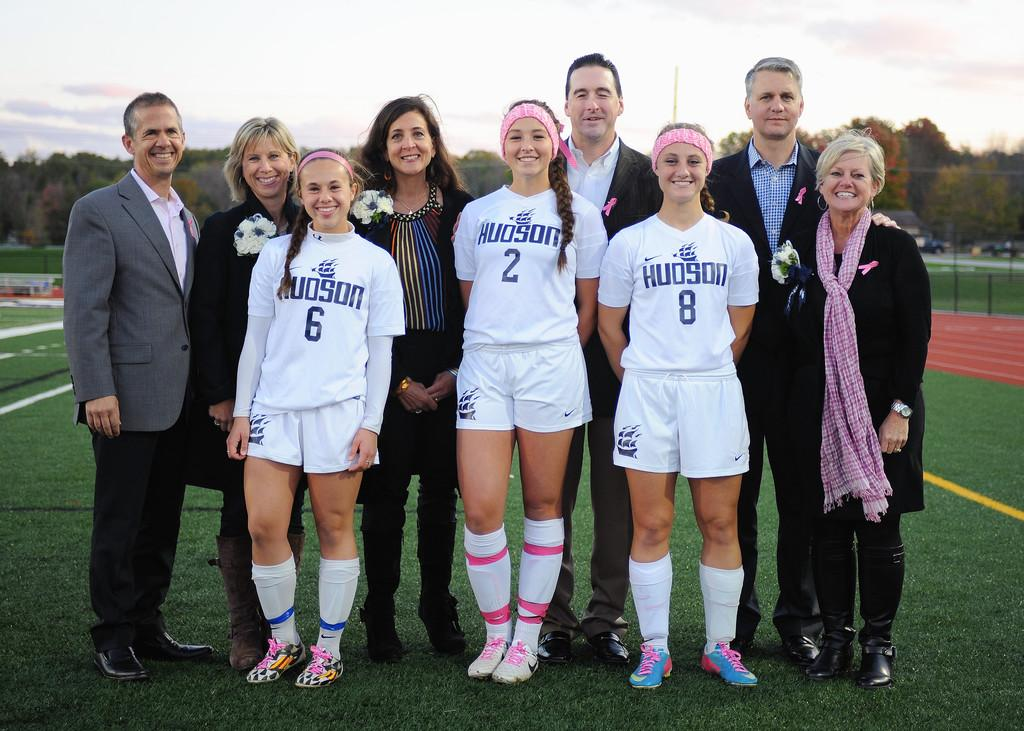<image>
Render a clear and concise summary of the photo. Three girls standing on a soccer field with adults and the girls have the word Hudson on their sports shirts. 